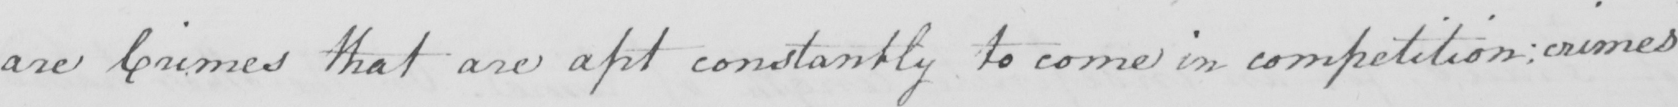What text is written in this handwritten line? are Crimes that are apt constantly to come in competition ; crimes 